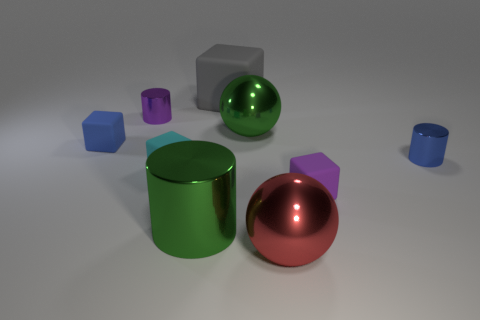Do the small blue object that is to the left of the red metallic sphere and the large gray object have the same shape?
Make the answer very short. Yes. There is a cylinder in front of the blue shiny object; what is it made of?
Provide a succinct answer. Metal. There is a shiny thing that is the same color as the large metal cylinder; what is its shape?
Make the answer very short. Sphere. Is there a big green ball that has the same material as the big cylinder?
Ensure brevity in your answer.  Yes. The cyan object is what size?
Provide a short and direct response. Small. What number of blue things are shiny cylinders or tiny shiny cylinders?
Provide a succinct answer. 1. What number of purple shiny things have the same shape as the small cyan object?
Provide a succinct answer. 0. How many blue metallic cylinders are the same size as the purple cube?
Offer a very short reply. 1. What material is the blue object that is the same shape as the gray rubber thing?
Offer a terse response. Rubber. There is a big shiny object on the left side of the green metallic ball; what is its color?
Your response must be concise. Green. 